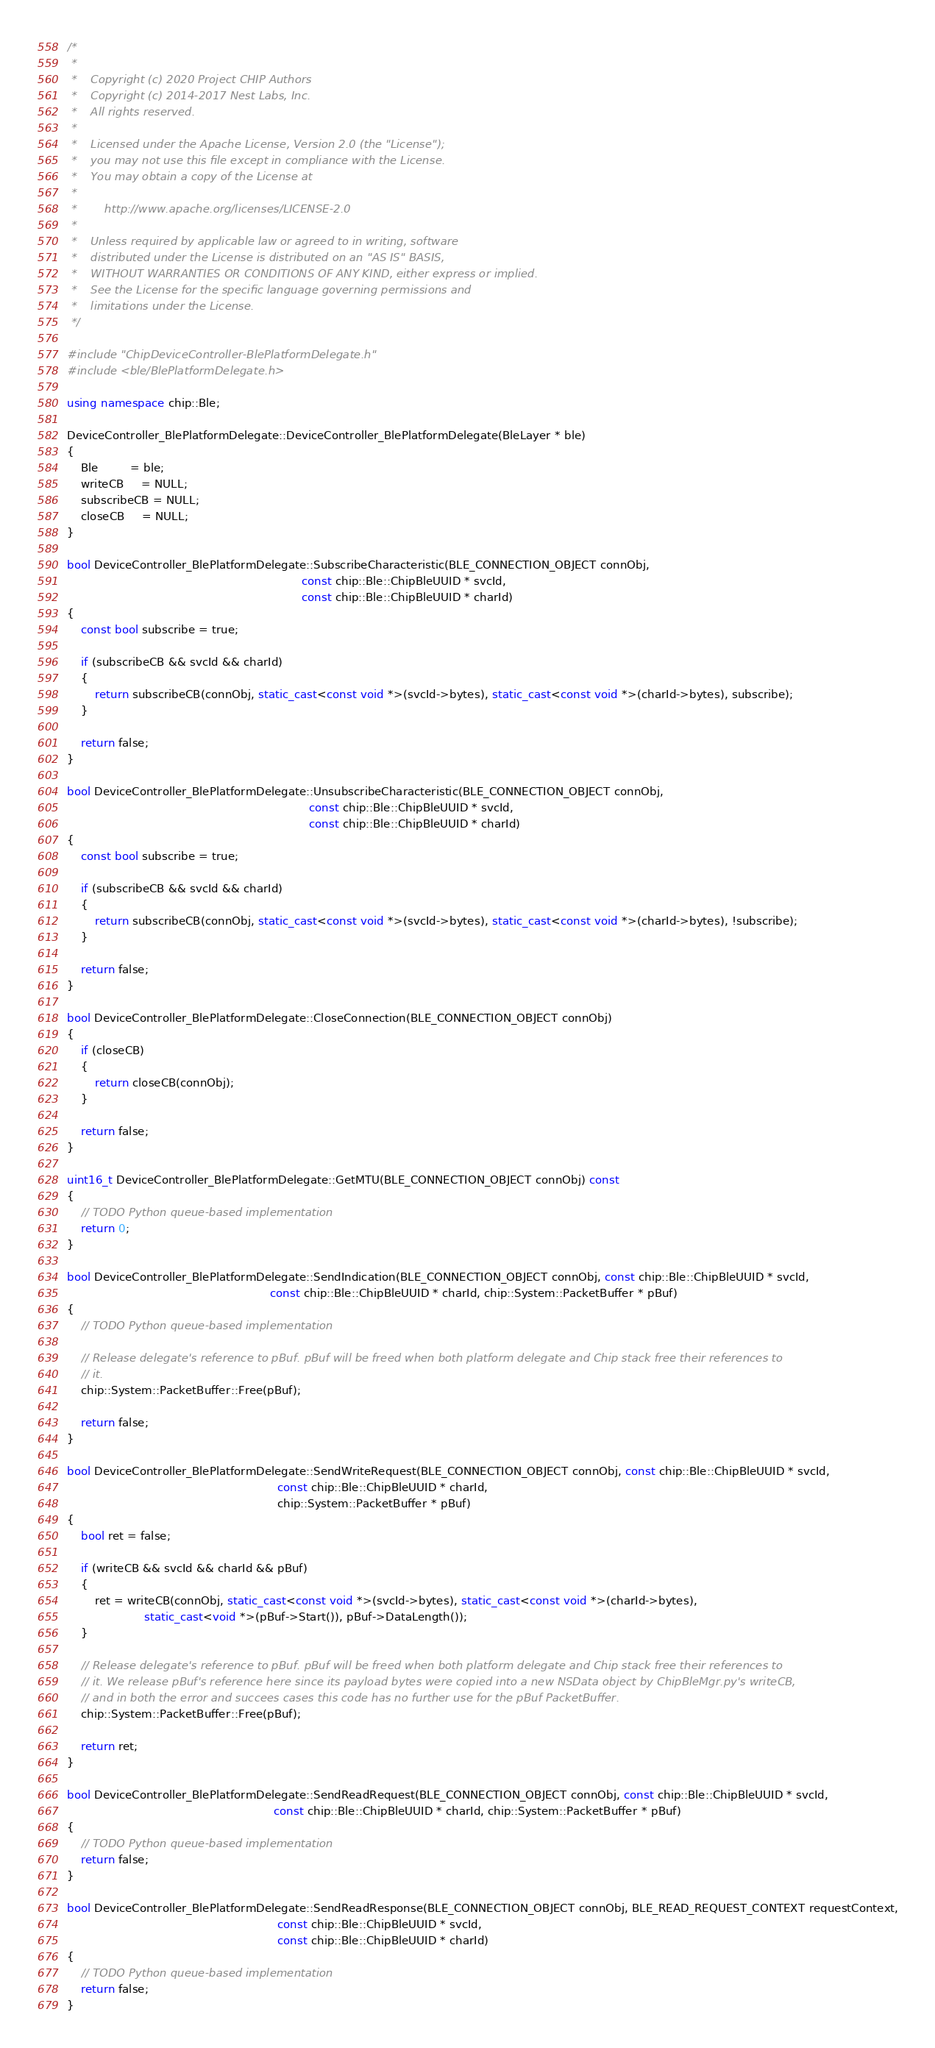Convert code to text. <code><loc_0><loc_0><loc_500><loc_500><_C++_>/*
 *
 *    Copyright (c) 2020 Project CHIP Authors
 *    Copyright (c) 2014-2017 Nest Labs, Inc.
 *    All rights reserved.
 *
 *    Licensed under the Apache License, Version 2.0 (the "License");
 *    you may not use this file except in compliance with the License.
 *    You may obtain a copy of the License at
 *
 *        http://www.apache.org/licenses/LICENSE-2.0
 *
 *    Unless required by applicable law or agreed to in writing, software
 *    distributed under the License is distributed on an "AS IS" BASIS,
 *    WITHOUT WARRANTIES OR CONDITIONS OF ANY KIND, either express or implied.
 *    See the License for the specific language governing permissions and
 *    limitations under the License.
 */

#include "ChipDeviceController-BlePlatformDelegate.h"
#include <ble/BlePlatformDelegate.h>

using namespace chip::Ble;

DeviceController_BlePlatformDelegate::DeviceController_BlePlatformDelegate(BleLayer * ble)
{
    Ble         = ble;
    writeCB     = NULL;
    subscribeCB = NULL;
    closeCB     = NULL;
}

bool DeviceController_BlePlatformDelegate::SubscribeCharacteristic(BLE_CONNECTION_OBJECT connObj,
                                                                   const chip::Ble::ChipBleUUID * svcId,
                                                                   const chip::Ble::ChipBleUUID * charId)
{
    const bool subscribe = true;

    if (subscribeCB && svcId && charId)
    {
        return subscribeCB(connObj, static_cast<const void *>(svcId->bytes), static_cast<const void *>(charId->bytes), subscribe);
    }

    return false;
}

bool DeviceController_BlePlatformDelegate::UnsubscribeCharacteristic(BLE_CONNECTION_OBJECT connObj,
                                                                     const chip::Ble::ChipBleUUID * svcId,
                                                                     const chip::Ble::ChipBleUUID * charId)
{
    const bool subscribe = true;

    if (subscribeCB && svcId && charId)
    {
        return subscribeCB(connObj, static_cast<const void *>(svcId->bytes), static_cast<const void *>(charId->bytes), !subscribe);
    }

    return false;
}

bool DeviceController_BlePlatformDelegate::CloseConnection(BLE_CONNECTION_OBJECT connObj)
{
    if (closeCB)
    {
        return closeCB(connObj);
    }

    return false;
}

uint16_t DeviceController_BlePlatformDelegate::GetMTU(BLE_CONNECTION_OBJECT connObj) const
{
    // TODO Python queue-based implementation
    return 0;
}

bool DeviceController_BlePlatformDelegate::SendIndication(BLE_CONNECTION_OBJECT connObj, const chip::Ble::ChipBleUUID * svcId,
                                                          const chip::Ble::ChipBleUUID * charId, chip::System::PacketBuffer * pBuf)
{
    // TODO Python queue-based implementation

    // Release delegate's reference to pBuf. pBuf will be freed when both platform delegate and Chip stack free their references to
    // it.
    chip::System::PacketBuffer::Free(pBuf);

    return false;
}

bool DeviceController_BlePlatformDelegate::SendWriteRequest(BLE_CONNECTION_OBJECT connObj, const chip::Ble::ChipBleUUID * svcId,
                                                            const chip::Ble::ChipBleUUID * charId,
                                                            chip::System::PacketBuffer * pBuf)
{
    bool ret = false;

    if (writeCB && svcId && charId && pBuf)
    {
        ret = writeCB(connObj, static_cast<const void *>(svcId->bytes), static_cast<const void *>(charId->bytes),
                      static_cast<void *>(pBuf->Start()), pBuf->DataLength());
    }

    // Release delegate's reference to pBuf. pBuf will be freed when both platform delegate and Chip stack free their references to
    // it. We release pBuf's reference here since its payload bytes were copied into a new NSData object by ChipBleMgr.py's writeCB,
    // and in both the error and succees cases this code has no further use for the pBuf PacketBuffer.
    chip::System::PacketBuffer::Free(pBuf);

    return ret;
}

bool DeviceController_BlePlatformDelegate::SendReadRequest(BLE_CONNECTION_OBJECT connObj, const chip::Ble::ChipBleUUID * svcId,
                                                           const chip::Ble::ChipBleUUID * charId, chip::System::PacketBuffer * pBuf)
{
    // TODO Python queue-based implementation
    return false;
}

bool DeviceController_BlePlatformDelegate::SendReadResponse(BLE_CONNECTION_OBJECT connObj, BLE_READ_REQUEST_CONTEXT requestContext,
                                                            const chip::Ble::ChipBleUUID * svcId,
                                                            const chip::Ble::ChipBleUUID * charId)
{
    // TODO Python queue-based implementation
    return false;
}
</code> 